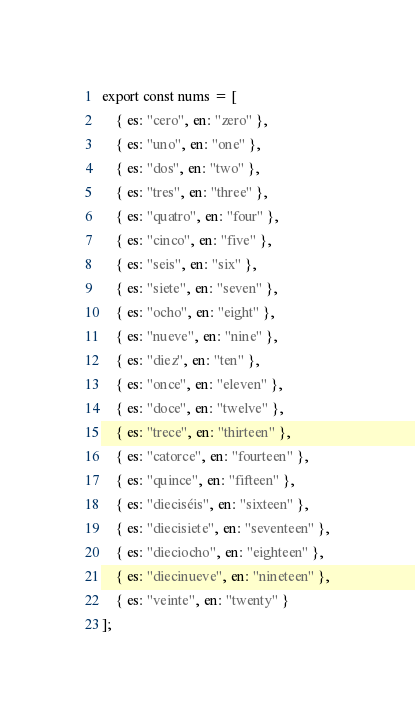<code> <loc_0><loc_0><loc_500><loc_500><_TypeScript_>export const nums = [
	{ es: "cero", en: "zero" },
	{ es: "uno", en: "one" },
	{ es: "dos", en: "two" },
	{ es: "tres", en: "three" },
	{ es: "quatro", en: "four" },
	{ es: "cinco", en: "five" },
	{ es: "seis", en: "six" },
	{ es: "siete", en: "seven" },
	{ es: "ocho", en: "eight" },
	{ es: "nueve", en: "nine" },
	{ es: "diez", en: "ten" },
	{ es: "once", en: "eleven" },
	{ es: "doce", en: "twelve" },
	{ es: "trece", en: "thirteen" },
	{ es: "catorce", en: "fourteen" },
	{ es: "quince", en: "fifteen" },
	{ es: "dieciséis", en: "sixteen" },
	{ es: "diecisiete", en: "seventeen" },
	{ es: "dieciocho", en: "eighteen" },
	{ es: "diecinueve", en: "nineteen" },
	{ es: "veinte", en: "twenty" }
];
</code> 